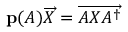Convert formula to latex. <formula><loc_0><loc_0><loc_500><loc_500>p ( A ) { \overrightarrow { X } } = { \overrightarrow { A X A ^ { \dagger } } }</formula> 